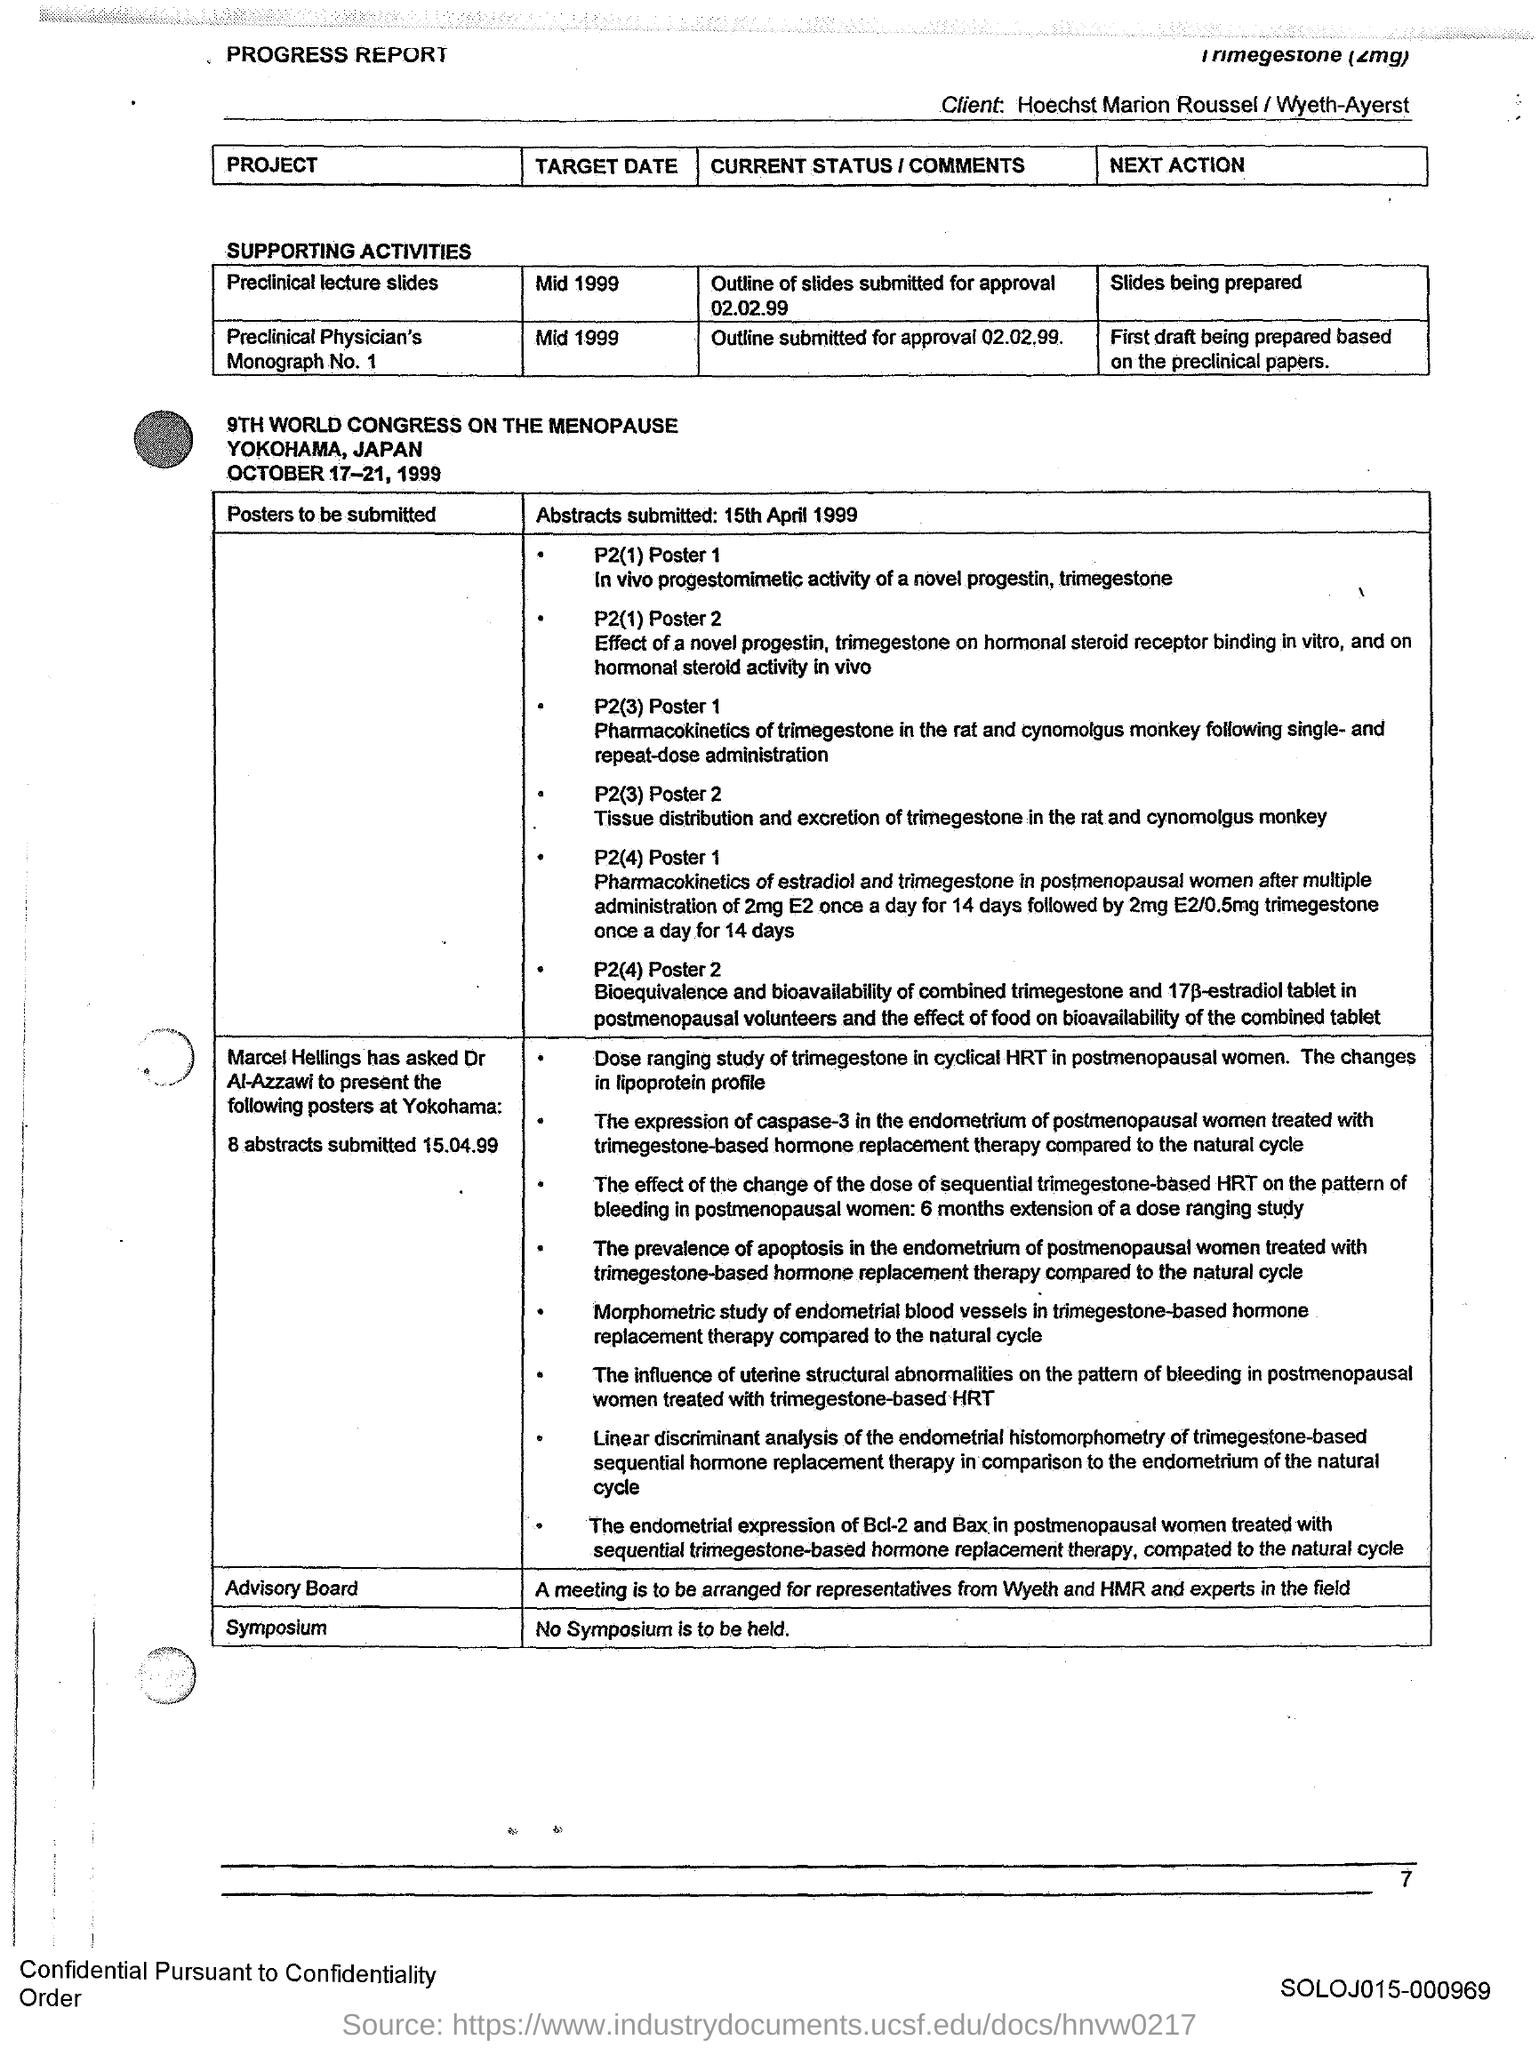What is the "Target Date" for "Project" "Preclinical lecture slides"?
Provide a succinct answer. Mid 1999. What is the "Target Date" for "Project" "Preclinical Physician's Monograph No. 1"?
Provide a succinct answer. MID 1999. 